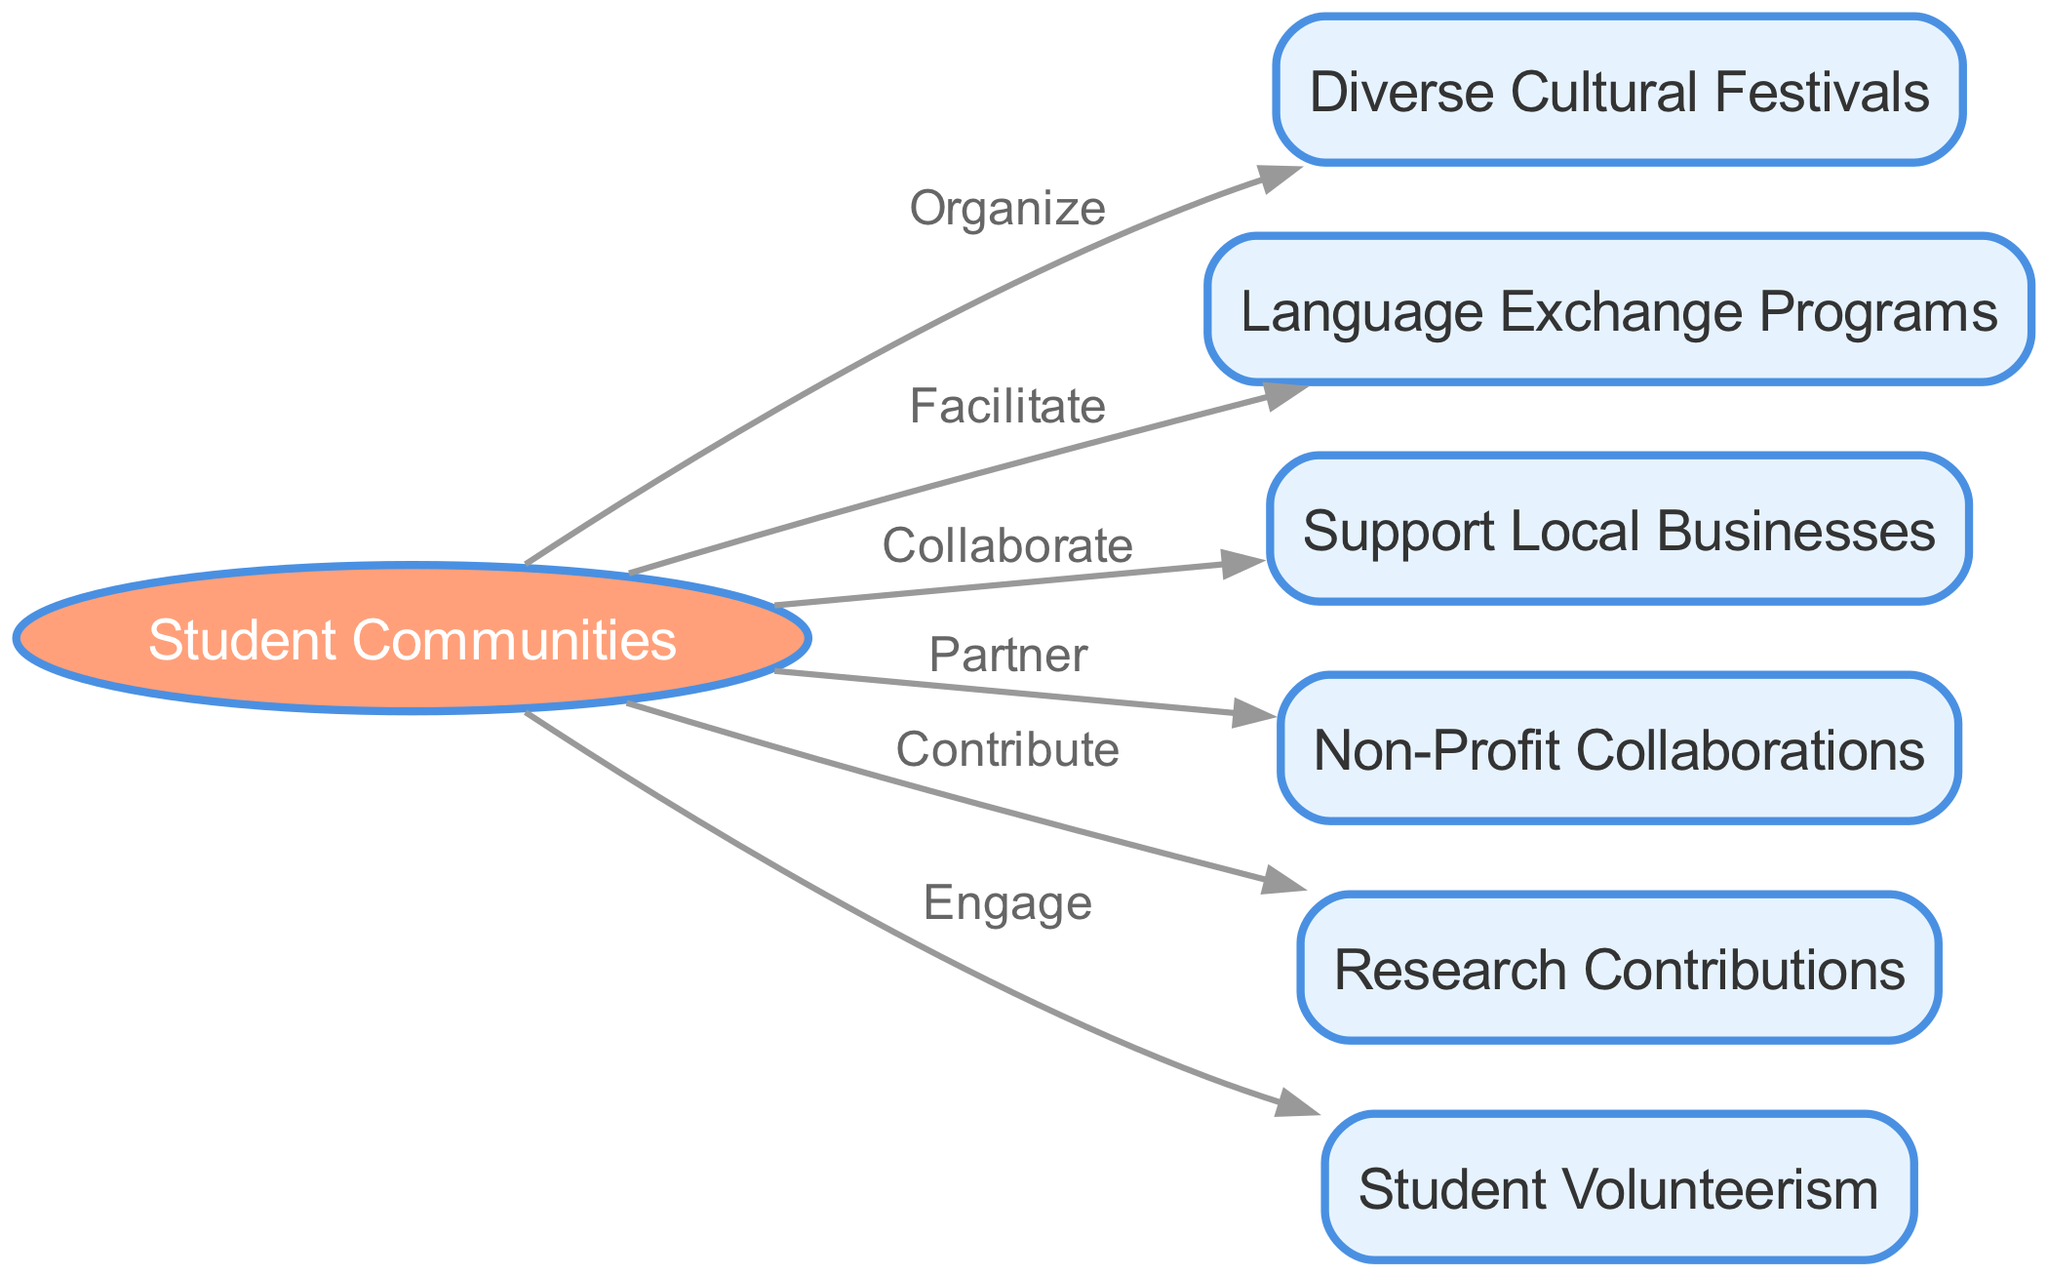What are the total number of nodes in the diagram? The diagram contains several nodes. By counting them, we find there are 7 nodes: Student Communities, Diverse Cultural Festivals, Language Exchange Programs, Support Local Businesses, Non-Profit Collaborations, Research Contributions, and Student Volunteerism.
Answer: 7 Which node does "Collaborate" connect to? In the diagram, the edge labeled "Collaborate" connects "Student Communities" to "Support Local Businesses". Therefore, the destination node associated with this edge is "Support Local Businesses".
Answer: Support Local Businesses How many edges are there from "Student Communities"? By inspecting the diagram, "Student Communities" has six outgoing edges connecting it to various nodes: Diverse Cultural Festivals, Language Exchange Programs, Support Local Businesses, Non-Profit Collaborations, Research Contributions, and Student Volunteerism. This totals to six edges.
Answer: 6 What action is associated with the edge from "student_communities" to "diverse_cultural_festivals"? The edge connecting "student_communities" to "diverse_cultural_festivals" is labeled "Organize", indicating that this action represents the interaction between these two nodes.
Answer: Organize Which node does "Engage" lead to? The edge labeled "Engage" leads from "Student Communities" to "Student Volunteerism". This indicates a direct connection between these two nodes.
Answer: Student Volunteerism If "Student Communities" did not exist, how would it affect other nodes? If "Student Communities" were absent, it would eliminate all direct connections to the other nodes since all edges originate from this single node. Thus, there would be no links to Diverse Cultural Festivals, Language Exchange Programs, Support Local Businesses, Non-Profit Collaborations, Research Contributions, and Student Volunteerism.
Answer: No connections Which type of contribution is labeled as a partnership in the diagram? The partnership action in the diagram is represented by the edge labeled "Partner", which connects "Student Communities" to "Non-Profit Collaborations". Therefore, “Non-Profit Collaborations” is the contribution type labeled as a partnership.
Answer: Non-Profit Collaborations 